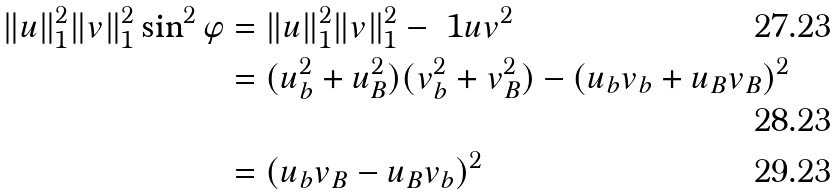<formula> <loc_0><loc_0><loc_500><loc_500>\| u \| _ { 1 } ^ { 2 } \| v \| _ { 1 } ^ { 2 } \sin ^ { 2 } \varphi & = \| u \| _ { 1 } ^ { 2 } \| v \| _ { 1 } ^ { 2 } - \ 1 u v ^ { 2 } \\ & = ( u _ { b } ^ { 2 } + u _ { B } ^ { 2 } ) ( v _ { b } ^ { 2 } + v _ { B } ^ { 2 } ) - ( u _ { b } v _ { b } + u _ { B } v _ { B } ) ^ { 2 } \\ & = ( u _ { b } v _ { B } - u _ { B } v _ { b } ) ^ { 2 }</formula> 